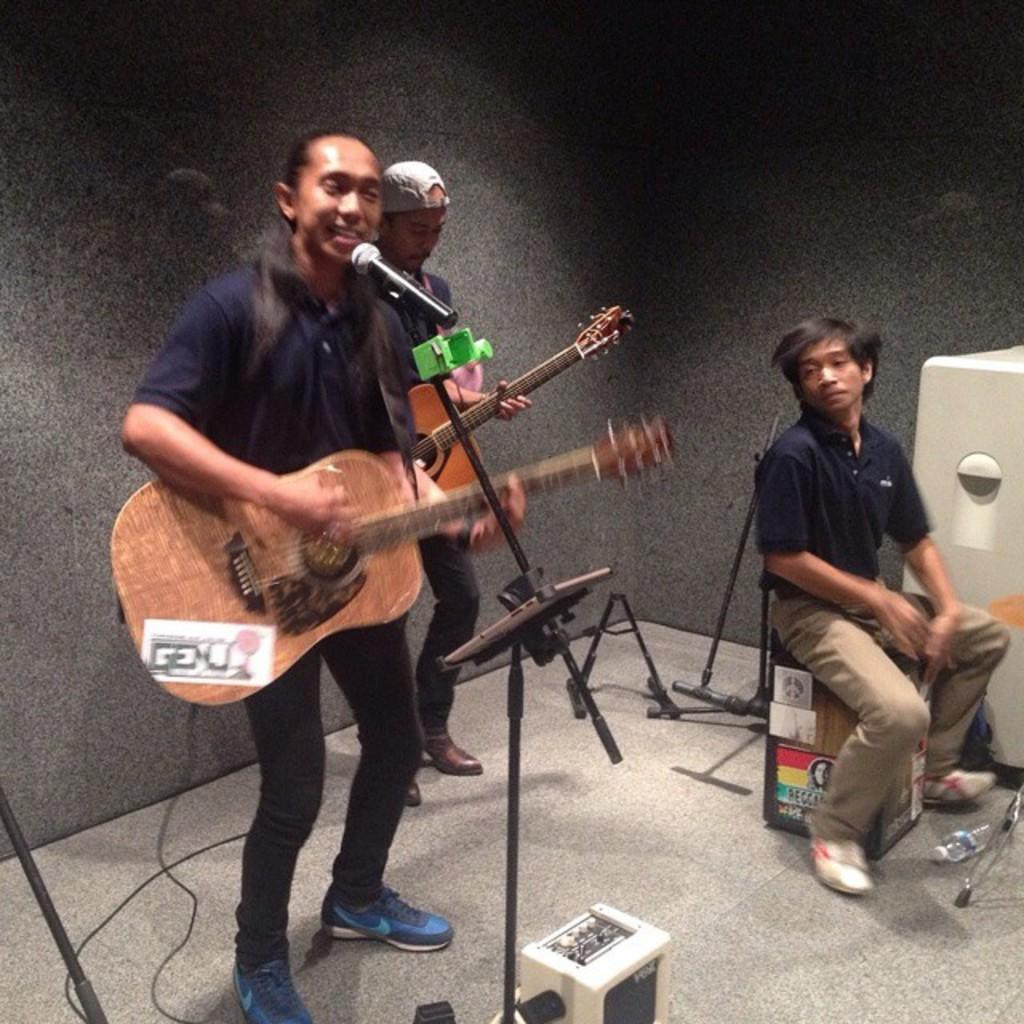How many people are in the image? There are three men in the image. Where are the men located in the image? The men are standing on a stage. What are the men doing in the image? The men are playing guitars. What time of day is it in the image, and can you see the sea in the background? The time of day is not mentioned in the image, and there is no sea visible in the background. Is there a rake being used by any of the men in the image? No, there is no rake present in the image; the men are playing guitars. 